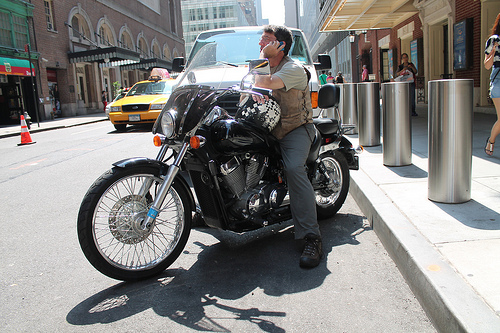Is the motorbike to the left or to the right of the orange cone?
Answer the question using a single word or phrase. Right Who is standing? People Does the woman's hair look blond? Yes Which kind of vehicle is to the left of the man? Taxi On which side of the photo is the woman? Right On which side of the image is the cone, the right or the left? Left Are there any people to the right of the woman on the right side? No Which place is it? City Do you see any motorcycles or trash cans? Yes Do you see any men to the left of the people on the side walk? Yes On which side is the taxi? Left How is the vehicle to the right of the cone called? Taxi Is the woman to the left or to the right of the motorcycle? Right Is the cab to the left or to the right of the man that is to the left of the people? Left 